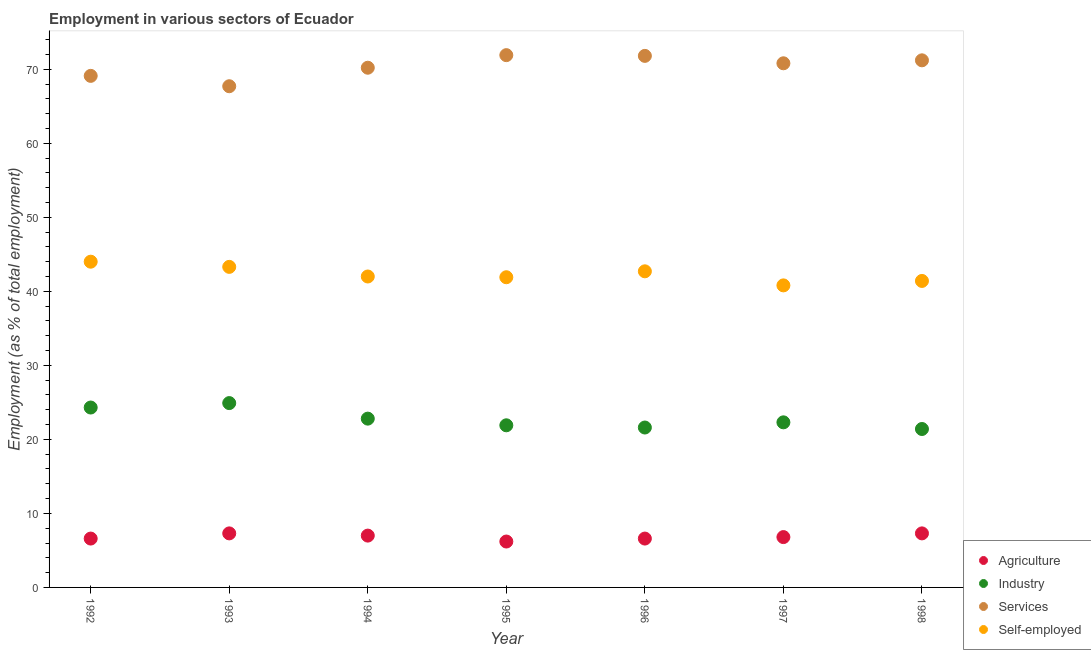Is the number of dotlines equal to the number of legend labels?
Provide a succinct answer. Yes. What is the percentage of workers in industry in 1996?
Provide a short and direct response. 21.6. Across all years, what is the maximum percentage of workers in agriculture?
Offer a terse response. 7.3. Across all years, what is the minimum percentage of workers in industry?
Offer a very short reply. 21.4. What is the total percentage of self employed workers in the graph?
Offer a terse response. 296.1. What is the difference between the percentage of workers in services in 1994 and that in 1998?
Ensure brevity in your answer.  -1. What is the difference between the percentage of workers in industry in 1993 and the percentage of workers in services in 1998?
Your answer should be very brief. -46.3. What is the average percentage of workers in services per year?
Make the answer very short. 70.39. In the year 1994, what is the difference between the percentage of workers in industry and percentage of self employed workers?
Your answer should be very brief. -19.2. In how many years, is the percentage of self employed workers greater than 12 %?
Give a very brief answer. 7. What is the ratio of the percentage of workers in agriculture in 1992 to that in 1994?
Offer a terse response. 0.94. Is the percentage of workers in services in 1994 less than that in 1998?
Offer a very short reply. Yes. What is the difference between the highest and the second highest percentage of self employed workers?
Provide a short and direct response. 0.7. What is the difference between the highest and the lowest percentage of workers in industry?
Keep it short and to the point. 3.5. Is it the case that in every year, the sum of the percentage of workers in agriculture and percentage of workers in industry is greater than the percentage of workers in services?
Keep it short and to the point. No. What is the difference between two consecutive major ticks on the Y-axis?
Provide a succinct answer. 10. Where does the legend appear in the graph?
Provide a succinct answer. Bottom right. What is the title of the graph?
Ensure brevity in your answer.  Employment in various sectors of Ecuador. Does "Management rating" appear as one of the legend labels in the graph?
Keep it short and to the point. No. What is the label or title of the X-axis?
Ensure brevity in your answer.  Year. What is the label or title of the Y-axis?
Provide a short and direct response. Employment (as % of total employment). What is the Employment (as % of total employment) of Agriculture in 1992?
Your response must be concise. 6.6. What is the Employment (as % of total employment) of Industry in 1992?
Make the answer very short. 24.3. What is the Employment (as % of total employment) in Services in 1992?
Provide a succinct answer. 69.1. What is the Employment (as % of total employment) in Agriculture in 1993?
Keep it short and to the point. 7.3. What is the Employment (as % of total employment) of Industry in 1993?
Offer a very short reply. 24.9. What is the Employment (as % of total employment) of Services in 1993?
Ensure brevity in your answer.  67.7. What is the Employment (as % of total employment) of Self-employed in 1993?
Ensure brevity in your answer.  43.3. What is the Employment (as % of total employment) of Industry in 1994?
Provide a succinct answer. 22.8. What is the Employment (as % of total employment) of Services in 1994?
Ensure brevity in your answer.  70.2. What is the Employment (as % of total employment) in Self-employed in 1994?
Your answer should be very brief. 42. What is the Employment (as % of total employment) of Agriculture in 1995?
Give a very brief answer. 6.2. What is the Employment (as % of total employment) of Industry in 1995?
Your answer should be compact. 21.9. What is the Employment (as % of total employment) in Services in 1995?
Your answer should be compact. 71.9. What is the Employment (as % of total employment) in Self-employed in 1995?
Provide a short and direct response. 41.9. What is the Employment (as % of total employment) of Agriculture in 1996?
Your answer should be compact. 6.6. What is the Employment (as % of total employment) in Industry in 1996?
Your answer should be very brief. 21.6. What is the Employment (as % of total employment) in Services in 1996?
Give a very brief answer. 71.8. What is the Employment (as % of total employment) in Self-employed in 1996?
Your response must be concise. 42.7. What is the Employment (as % of total employment) of Agriculture in 1997?
Your response must be concise. 6.8. What is the Employment (as % of total employment) of Industry in 1997?
Ensure brevity in your answer.  22.3. What is the Employment (as % of total employment) of Services in 1997?
Your answer should be very brief. 70.8. What is the Employment (as % of total employment) in Self-employed in 1997?
Offer a very short reply. 40.8. What is the Employment (as % of total employment) of Agriculture in 1998?
Keep it short and to the point. 7.3. What is the Employment (as % of total employment) of Industry in 1998?
Your response must be concise. 21.4. What is the Employment (as % of total employment) of Services in 1998?
Your answer should be compact. 71.2. What is the Employment (as % of total employment) in Self-employed in 1998?
Make the answer very short. 41.4. Across all years, what is the maximum Employment (as % of total employment) of Agriculture?
Your answer should be compact. 7.3. Across all years, what is the maximum Employment (as % of total employment) of Industry?
Make the answer very short. 24.9. Across all years, what is the maximum Employment (as % of total employment) in Services?
Make the answer very short. 71.9. Across all years, what is the minimum Employment (as % of total employment) of Agriculture?
Give a very brief answer. 6.2. Across all years, what is the minimum Employment (as % of total employment) of Industry?
Make the answer very short. 21.4. Across all years, what is the minimum Employment (as % of total employment) in Services?
Your answer should be very brief. 67.7. Across all years, what is the minimum Employment (as % of total employment) in Self-employed?
Offer a very short reply. 40.8. What is the total Employment (as % of total employment) in Agriculture in the graph?
Keep it short and to the point. 47.8. What is the total Employment (as % of total employment) in Industry in the graph?
Keep it short and to the point. 159.2. What is the total Employment (as % of total employment) of Services in the graph?
Give a very brief answer. 492.7. What is the total Employment (as % of total employment) of Self-employed in the graph?
Your answer should be compact. 296.1. What is the difference between the Employment (as % of total employment) in Agriculture in 1992 and that in 1993?
Give a very brief answer. -0.7. What is the difference between the Employment (as % of total employment) of Self-employed in 1992 and that in 1993?
Make the answer very short. 0.7. What is the difference between the Employment (as % of total employment) in Agriculture in 1992 and that in 1994?
Give a very brief answer. -0.4. What is the difference between the Employment (as % of total employment) of Industry in 1992 and that in 1994?
Keep it short and to the point. 1.5. What is the difference between the Employment (as % of total employment) in Services in 1992 and that in 1994?
Your answer should be very brief. -1.1. What is the difference between the Employment (as % of total employment) of Self-employed in 1992 and that in 1994?
Offer a very short reply. 2. What is the difference between the Employment (as % of total employment) of Industry in 1992 and that in 1995?
Your answer should be compact. 2.4. What is the difference between the Employment (as % of total employment) in Self-employed in 1992 and that in 1995?
Offer a very short reply. 2.1. What is the difference between the Employment (as % of total employment) in Industry in 1992 and that in 1996?
Give a very brief answer. 2.7. What is the difference between the Employment (as % of total employment) of Services in 1992 and that in 1997?
Offer a terse response. -1.7. What is the difference between the Employment (as % of total employment) of Agriculture in 1992 and that in 1998?
Make the answer very short. -0.7. What is the difference between the Employment (as % of total employment) of Services in 1992 and that in 1998?
Ensure brevity in your answer.  -2.1. What is the difference between the Employment (as % of total employment) of Self-employed in 1992 and that in 1998?
Provide a succinct answer. 2.6. What is the difference between the Employment (as % of total employment) in Agriculture in 1993 and that in 1994?
Provide a short and direct response. 0.3. What is the difference between the Employment (as % of total employment) of Industry in 1993 and that in 1994?
Offer a terse response. 2.1. What is the difference between the Employment (as % of total employment) of Agriculture in 1993 and that in 1995?
Keep it short and to the point. 1.1. What is the difference between the Employment (as % of total employment) in Industry in 1993 and that in 1995?
Ensure brevity in your answer.  3. What is the difference between the Employment (as % of total employment) of Self-employed in 1993 and that in 1995?
Offer a terse response. 1.4. What is the difference between the Employment (as % of total employment) in Industry in 1993 and that in 1996?
Your response must be concise. 3.3. What is the difference between the Employment (as % of total employment) of Services in 1993 and that in 1996?
Offer a terse response. -4.1. What is the difference between the Employment (as % of total employment) of Industry in 1993 and that in 1997?
Offer a terse response. 2.6. What is the difference between the Employment (as % of total employment) in Agriculture in 1993 and that in 1998?
Your answer should be compact. 0. What is the difference between the Employment (as % of total employment) in Industry in 1993 and that in 1998?
Make the answer very short. 3.5. What is the difference between the Employment (as % of total employment) in Services in 1993 and that in 1998?
Your answer should be very brief. -3.5. What is the difference between the Employment (as % of total employment) in Self-employed in 1993 and that in 1998?
Your answer should be compact. 1.9. What is the difference between the Employment (as % of total employment) of Industry in 1994 and that in 1995?
Your response must be concise. 0.9. What is the difference between the Employment (as % of total employment) in Self-employed in 1994 and that in 1995?
Make the answer very short. 0.1. What is the difference between the Employment (as % of total employment) in Industry in 1994 and that in 1996?
Ensure brevity in your answer.  1.2. What is the difference between the Employment (as % of total employment) of Services in 1994 and that in 1996?
Your answer should be compact. -1.6. What is the difference between the Employment (as % of total employment) in Agriculture in 1994 and that in 1997?
Offer a terse response. 0.2. What is the difference between the Employment (as % of total employment) in Industry in 1994 and that in 1997?
Keep it short and to the point. 0.5. What is the difference between the Employment (as % of total employment) of Services in 1994 and that in 1997?
Give a very brief answer. -0.6. What is the difference between the Employment (as % of total employment) of Self-employed in 1994 and that in 1997?
Give a very brief answer. 1.2. What is the difference between the Employment (as % of total employment) in Self-employed in 1994 and that in 1998?
Provide a succinct answer. 0.6. What is the difference between the Employment (as % of total employment) in Industry in 1995 and that in 1996?
Provide a succinct answer. 0.3. What is the difference between the Employment (as % of total employment) of Industry in 1995 and that in 1997?
Give a very brief answer. -0.4. What is the difference between the Employment (as % of total employment) of Self-employed in 1995 and that in 1997?
Offer a terse response. 1.1. What is the difference between the Employment (as % of total employment) of Self-employed in 1996 and that in 1997?
Ensure brevity in your answer.  1.9. What is the difference between the Employment (as % of total employment) of Agriculture in 1996 and that in 1998?
Your answer should be compact. -0.7. What is the difference between the Employment (as % of total employment) of Self-employed in 1996 and that in 1998?
Your response must be concise. 1.3. What is the difference between the Employment (as % of total employment) in Agriculture in 1992 and the Employment (as % of total employment) in Industry in 1993?
Offer a terse response. -18.3. What is the difference between the Employment (as % of total employment) of Agriculture in 1992 and the Employment (as % of total employment) of Services in 1993?
Your answer should be very brief. -61.1. What is the difference between the Employment (as % of total employment) in Agriculture in 1992 and the Employment (as % of total employment) in Self-employed in 1993?
Make the answer very short. -36.7. What is the difference between the Employment (as % of total employment) in Industry in 1992 and the Employment (as % of total employment) in Services in 1993?
Your answer should be very brief. -43.4. What is the difference between the Employment (as % of total employment) of Services in 1992 and the Employment (as % of total employment) of Self-employed in 1993?
Provide a succinct answer. 25.8. What is the difference between the Employment (as % of total employment) in Agriculture in 1992 and the Employment (as % of total employment) in Industry in 1994?
Your answer should be compact. -16.2. What is the difference between the Employment (as % of total employment) in Agriculture in 1992 and the Employment (as % of total employment) in Services in 1994?
Provide a short and direct response. -63.6. What is the difference between the Employment (as % of total employment) of Agriculture in 1992 and the Employment (as % of total employment) of Self-employed in 1994?
Your response must be concise. -35.4. What is the difference between the Employment (as % of total employment) of Industry in 1992 and the Employment (as % of total employment) of Services in 1994?
Your answer should be compact. -45.9. What is the difference between the Employment (as % of total employment) of Industry in 1992 and the Employment (as % of total employment) of Self-employed in 1994?
Give a very brief answer. -17.7. What is the difference between the Employment (as % of total employment) in Services in 1992 and the Employment (as % of total employment) in Self-employed in 1994?
Ensure brevity in your answer.  27.1. What is the difference between the Employment (as % of total employment) of Agriculture in 1992 and the Employment (as % of total employment) of Industry in 1995?
Offer a very short reply. -15.3. What is the difference between the Employment (as % of total employment) of Agriculture in 1992 and the Employment (as % of total employment) of Services in 1995?
Ensure brevity in your answer.  -65.3. What is the difference between the Employment (as % of total employment) in Agriculture in 1992 and the Employment (as % of total employment) in Self-employed in 1995?
Your answer should be very brief. -35.3. What is the difference between the Employment (as % of total employment) in Industry in 1992 and the Employment (as % of total employment) in Services in 1995?
Your answer should be compact. -47.6. What is the difference between the Employment (as % of total employment) of Industry in 1992 and the Employment (as % of total employment) of Self-employed in 1995?
Your response must be concise. -17.6. What is the difference between the Employment (as % of total employment) in Services in 1992 and the Employment (as % of total employment) in Self-employed in 1995?
Offer a very short reply. 27.2. What is the difference between the Employment (as % of total employment) in Agriculture in 1992 and the Employment (as % of total employment) in Services in 1996?
Offer a very short reply. -65.2. What is the difference between the Employment (as % of total employment) in Agriculture in 1992 and the Employment (as % of total employment) in Self-employed in 1996?
Provide a short and direct response. -36.1. What is the difference between the Employment (as % of total employment) of Industry in 1992 and the Employment (as % of total employment) of Services in 1996?
Your response must be concise. -47.5. What is the difference between the Employment (as % of total employment) of Industry in 1992 and the Employment (as % of total employment) of Self-employed in 1996?
Make the answer very short. -18.4. What is the difference between the Employment (as % of total employment) in Services in 1992 and the Employment (as % of total employment) in Self-employed in 1996?
Your answer should be very brief. 26.4. What is the difference between the Employment (as % of total employment) in Agriculture in 1992 and the Employment (as % of total employment) in Industry in 1997?
Make the answer very short. -15.7. What is the difference between the Employment (as % of total employment) in Agriculture in 1992 and the Employment (as % of total employment) in Services in 1997?
Keep it short and to the point. -64.2. What is the difference between the Employment (as % of total employment) of Agriculture in 1992 and the Employment (as % of total employment) of Self-employed in 1997?
Give a very brief answer. -34.2. What is the difference between the Employment (as % of total employment) of Industry in 1992 and the Employment (as % of total employment) of Services in 1997?
Your answer should be compact. -46.5. What is the difference between the Employment (as % of total employment) of Industry in 1992 and the Employment (as % of total employment) of Self-employed in 1997?
Offer a very short reply. -16.5. What is the difference between the Employment (as % of total employment) in Services in 1992 and the Employment (as % of total employment) in Self-employed in 1997?
Provide a succinct answer. 28.3. What is the difference between the Employment (as % of total employment) in Agriculture in 1992 and the Employment (as % of total employment) in Industry in 1998?
Offer a terse response. -14.8. What is the difference between the Employment (as % of total employment) of Agriculture in 1992 and the Employment (as % of total employment) of Services in 1998?
Your answer should be very brief. -64.6. What is the difference between the Employment (as % of total employment) of Agriculture in 1992 and the Employment (as % of total employment) of Self-employed in 1998?
Your answer should be very brief. -34.8. What is the difference between the Employment (as % of total employment) in Industry in 1992 and the Employment (as % of total employment) in Services in 1998?
Keep it short and to the point. -46.9. What is the difference between the Employment (as % of total employment) in Industry in 1992 and the Employment (as % of total employment) in Self-employed in 1998?
Make the answer very short. -17.1. What is the difference between the Employment (as % of total employment) of Services in 1992 and the Employment (as % of total employment) of Self-employed in 1998?
Keep it short and to the point. 27.7. What is the difference between the Employment (as % of total employment) of Agriculture in 1993 and the Employment (as % of total employment) of Industry in 1994?
Give a very brief answer. -15.5. What is the difference between the Employment (as % of total employment) of Agriculture in 1993 and the Employment (as % of total employment) of Services in 1994?
Offer a very short reply. -62.9. What is the difference between the Employment (as % of total employment) of Agriculture in 1993 and the Employment (as % of total employment) of Self-employed in 1994?
Offer a very short reply. -34.7. What is the difference between the Employment (as % of total employment) of Industry in 1993 and the Employment (as % of total employment) of Services in 1994?
Offer a terse response. -45.3. What is the difference between the Employment (as % of total employment) of Industry in 1993 and the Employment (as % of total employment) of Self-employed in 1994?
Give a very brief answer. -17.1. What is the difference between the Employment (as % of total employment) in Services in 1993 and the Employment (as % of total employment) in Self-employed in 1994?
Your answer should be very brief. 25.7. What is the difference between the Employment (as % of total employment) of Agriculture in 1993 and the Employment (as % of total employment) of Industry in 1995?
Offer a very short reply. -14.6. What is the difference between the Employment (as % of total employment) in Agriculture in 1993 and the Employment (as % of total employment) in Services in 1995?
Offer a terse response. -64.6. What is the difference between the Employment (as % of total employment) of Agriculture in 1993 and the Employment (as % of total employment) of Self-employed in 1995?
Offer a terse response. -34.6. What is the difference between the Employment (as % of total employment) of Industry in 1993 and the Employment (as % of total employment) of Services in 1995?
Your response must be concise. -47. What is the difference between the Employment (as % of total employment) of Industry in 1993 and the Employment (as % of total employment) of Self-employed in 1995?
Your answer should be very brief. -17. What is the difference between the Employment (as % of total employment) of Services in 1993 and the Employment (as % of total employment) of Self-employed in 1995?
Your answer should be compact. 25.8. What is the difference between the Employment (as % of total employment) of Agriculture in 1993 and the Employment (as % of total employment) of Industry in 1996?
Ensure brevity in your answer.  -14.3. What is the difference between the Employment (as % of total employment) of Agriculture in 1993 and the Employment (as % of total employment) of Services in 1996?
Give a very brief answer. -64.5. What is the difference between the Employment (as % of total employment) in Agriculture in 1993 and the Employment (as % of total employment) in Self-employed in 1996?
Provide a succinct answer. -35.4. What is the difference between the Employment (as % of total employment) in Industry in 1993 and the Employment (as % of total employment) in Services in 1996?
Offer a terse response. -46.9. What is the difference between the Employment (as % of total employment) in Industry in 1993 and the Employment (as % of total employment) in Self-employed in 1996?
Give a very brief answer. -17.8. What is the difference between the Employment (as % of total employment) of Services in 1993 and the Employment (as % of total employment) of Self-employed in 1996?
Ensure brevity in your answer.  25. What is the difference between the Employment (as % of total employment) of Agriculture in 1993 and the Employment (as % of total employment) of Industry in 1997?
Keep it short and to the point. -15. What is the difference between the Employment (as % of total employment) of Agriculture in 1993 and the Employment (as % of total employment) of Services in 1997?
Provide a short and direct response. -63.5. What is the difference between the Employment (as % of total employment) in Agriculture in 1993 and the Employment (as % of total employment) in Self-employed in 1997?
Make the answer very short. -33.5. What is the difference between the Employment (as % of total employment) in Industry in 1993 and the Employment (as % of total employment) in Services in 1997?
Keep it short and to the point. -45.9. What is the difference between the Employment (as % of total employment) of Industry in 1993 and the Employment (as % of total employment) of Self-employed in 1997?
Provide a succinct answer. -15.9. What is the difference between the Employment (as % of total employment) of Services in 1993 and the Employment (as % of total employment) of Self-employed in 1997?
Make the answer very short. 26.9. What is the difference between the Employment (as % of total employment) in Agriculture in 1993 and the Employment (as % of total employment) in Industry in 1998?
Ensure brevity in your answer.  -14.1. What is the difference between the Employment (as % of total employment) in Agriculture in 1993 and the Employment (as % of total employment) in Services in 1998?
Ensure brevity in your answer.  -63.9. What is the difference between the Employment (as % of total employment) of Agriculture in 1993 and the Employment (as % of total employment) of Self-employed in 1998?
Your answer should be compact. -34.1. What is the difference between the Employment (as % of total employment) of Industry in 1993 and the Employment (as % of total employment) of Services in 1998?
Make the answer very short. -46.3. What is the difference between the Employment (as % of total employment) of Industry in 1993 and the Employment (as % of total employment) of Self-employed in 1998?
Offer a very short reply. -16.5. What is the difference between the Employment (as % of total employment) of Services in 1993 and the Employment (as % of total employment) of Self-employed in 1998?
Give a very brief answer. 26.3. What is the difference between the Employment (as % of total employment) in Agriculture in 1994 and the Employment (as % of total employment) in Industry in 1995?
Provide a short and direct response. -14.9. What is the difference between the Employment (as % of total employment) in Agriculture in 1994 and the Employment (as % of total employment) in Services in 1995?
Keep it short and to the point. -64.9. What is the difference between the Employment (as % of total employment) of Agriculture in 1994 and the Employment (as % of total employment) of Self-employed in 1995?
Your answer should be compact. -34.9. What is the difference between the Employment (as % of total employment) of Industry in 1994 and the Employment (as % of total employment) of Services in 1995?
Provide a succinct answer. -49.1. What is the difference between the Employment (as % of total employment) of Industry in 1994 and the Employment (as % of total employment) of Self-employed in 1995?
Offer a very short reply. -19.1. What is the difference between the Employment (as % of total employment) in Services in 1994 and the Employment (as % of total employment) in Self-employed in 1995?
Ensure brevity in your answer.  28.3. What is the difference between the Employment (as % of total employment) in Agriculture in 1994 and the Employment (as % of total employment) in Industry in 1996?
Your answer should be compact. -14.6. What is the difference between the Employment (as % of total employment) in Agriculture in 1994 and the Employment (as % of total employment) in Services in 1996?
Your answer should be very brief. -64.8. What is the difference between the Employment (as % of total employment) in Agriculture in 1994 and the Employment (as % of total employment) in Self-employed in 1996?
Provide a short and direct response. -35.7. What is the difference between the Employment (as % of total employment) in Industry in 1994 and the Employment (as % of total employment) in Services in 1996?
Offer a very short reply. -49. What is the difference between the Employment (as % of total employment) in Industry in 1994 and the Employment (as % of total employment) in Self-employed in 1996?
Provide a succinct answer. -19.9. What is the difference between the Employment (as % of total employment) in Services in 1994 and the Employment (as % of total employment) in Self-employed in 1996?
Ensure brevity in your answer.  27.5. What is the difference between the Employment (as % of total employment) of Agriculture in 1994 and the Employment (as % of total employment) of Industry in 1997?
Give a very brief answer. -15.3. What is the difference between the Employment (as % of total employment) of Agriculture in 1994 and the Employment (as % of total employment) of Services in 1997?
Offer a very short reply. -63.8. What is the difference between the Employment (as % of total employment) in Agriculture in 1994 and the Employment (as % of total employment) in Self-employed in 1997?
Make the answer very short. -33.8. What is the difference between the Employment (as % of total employment) of Industry in 1994 and the Employment (as % of total employment) of Services in 1997?
Ensure brevity in your answer.  -48. What is the difference between the Employment (as % of total employment) of Services in 1994 and the Employment (as % of total employment) of Self-employed in 1997?
Offer a very short reply. 29.4. What is the difference between the Employment (as % of total employment) in Agriculture in 1994 and the Employment (as % of total employment) in Industry in 1998?
Keep it short and to the point. -14.4. What is the difference between the Employment (as % of total employment) of Agriculture in 1994 and the Employment (as % of total employment) of Services in 1998?
Offer a terse response. -64.2. What is the difference between the Employment (as % of total employment) in Agriculture in 1994 and the Employment (as % of total employment) in Self-employed in 1998?
Your answer should be compact. -34.4. What is the difference between the Employment (as % of total employment) of Industry in 1994 and the Employment (as % of total employment) of Services in 1998?
Keep it short and to the point. -48.4. What is the difference between the Employment (as % of total employment) in Industry in 1994 and the Employment (as % of total employment) in Self-employed in 1998?
Provide a succinct answer. -18.6. What is the difference between the Employment (as % of total employment) of Services in 1994 and the Employment (as % of total employment) of Self-employed in 1998?
Provide a succinct answer. 28.8. What is the difference between the Employment (as % of total employment) in Agriculture in 1995 and the Employment (as % of total employment) in Industry in 1996?
Offer a very short reply. -15.4. What is the difference between the Employment (as % of total employment) in Agriculture in 1995 and the Employment (as % of total employment) in Services in 1996?
Provide a short and direct response. -65.6. What is the difference between the Employment (as % of total employment) of Agriculture in 1995 and the Employment (as % of total employment) of Self-employed in 1996?
Your answer should be compact. -36.5. What is the difference between the Employment (as % of total employment) of Industry in 1995 and the Employment (as % of total employment) of Services in 1996?
Provide a short and direct response. -49.9. What is the difference between the Employment (as % of total employment) of Industry in 1995 and the Employment (as % of total employment) of Self-employed in 1996?
Provide a short and direct response. -20.8. What is the difference between the Employment (as % of total employment) of Services in 1995 and the Employment (as % of total employment) of Self-employed in 1996?
Your answer should be compact. 29.2. What is the difference between the Employment (as % of total employment) of Agriculture in 1995 and the Employment (as % of total employment) of Industry in 1997?
Your answer should be very brief. -16.1. What is the difference between the Employment (as % of total employment) of Agriculture in 1995 and the Employment (as % of total employment) of Services in 1997?
Offer a very short reply. -64.6. What is the difference between the Employment (as % of total employment) in Agriculture in 1995 and the Employment (as % of total employment) in Self-employed in 1997?
Give a very brief answer. -34.6. What is the difference between the Employment (as % of total employment) of Industry in 1995 and the Employment (as % of total employment) of Services in 1997?
Ensure brevity in your answer.  -48.9. What is the difference between the Employment (as % of total employment) of Industry in 1995 and the Employment (as % of total employment) of Self-employed in 1997?
Your response must be concise. -18.9. What is the difference between the Employment (as % of total employment) of Services in 1995 and the Employment (as % of total employment) of Self-employed in 1997?
Offer a very short reply. 31.1. What is the difference between the Employment (as % of total employment) of Agriculture in 1995 and the Employment (as % of total employment) of Industry in 1998?
Make the answer very short. -15.2. What is the difference between the Employment (as % of total employment) in Agriculture in 1995 and the Employment (as % of total employment) in Services in 1998?
Provide a succinct answer. -65. What is the difference between the Employment (as % of total employment) of Agriculture in 1995 and the Employment (as % of total employment) of Self-employed in 1998?
Offer a very short reply. -35.2. What is the difference between the Employment (as % of total employment) in Industry in 1995 and the Employment (as % of total employment) in Services in 1998?
Make the answer very short. -49.3. What is the difference between the Employment (as % of total employment) of Industry in 1995 and the Employment (as % of total employment) of Self-employed in 1998?
Provide a succinct answer. -19.5. What is the difference between the Employment (as % of total employment) of Services in 1995 and the Employment (as % of total employment) of Self-employed in 1998?
Give a very brief answer. 30.5. What is the difference between the Employment (as % of total employment) in Agriculture in 1996 and the Employment (as % of total employment) in Industry in 1997?
Your answer should be very brief. -15.7. What is the difference between the Employment (as % of total employment) in Agriculture in 1996 and the Employment (as % of total employment) in Services in 1997?
Offer a very short reply. -64.2. What is the difference between the Employment (as % of total employment) in Agriculture in 1996 and the Employment (as % of total employment) in Self-employed in 1997?
Provide a succinct answer. -34.2. What is the difference between the Employment (as % of total employment) in Industry in 1996 and the Employment (as % of total employment) in Services in 1997?
Make the answer very short. -49.2. What is the difference between the Employment (as % of total employment) of Industry in 1996 and the Employment (as % of total employment) of Self-employed in 1997?
Provide a succinct answer. -19.2. What is the difference between the Employment (as % of total employment) of Services in 1996 and the Employment (as % of total employment) of Self-employed in 1997?
Offer a very short reply. 31. What is the difference between the Employment (as % of total employment) of Agriculture in 1996 and the Employment (as % of total employment) of Industry in 1998?
Your answer should be compact. -14.8. What is the difference between the Employment (as % of total employment) of Agriculture in 1996 and the Employment (as % of total employment) of Services in 1998?
Provide a short and direct response. -64.6. What is the difference between the Employment (as % of total employment) of Agriculture in 1996 and the Employment (as % of total employment) of Self-employed in 1998?
Keep it short and to the point. -34.8. What is the difference between the Employment (as % of total employment) of Industry in 1996 and the Employment (as % of total employment) of Services in 1998?
Provide a short and direct response. -49.6. What is the difference between the Employment (as % of total employment) in Industry in 1996 and the Employment (as % of total employment) in Self-employed in 1998?
Offer a terse response. -19.8. What is the difference between the Employment (as % of total employment) in Services in 1996 and the Employment (as % of total employment) in Self-employed in 1998?
Keep it short and to the point. 30.4. What is the difference between the Employment (as % of total employment) in Agriculture in 1997 and the Employment (as % of total employment) in Industry in 1998?
Offer a very short reply. -14.6. What is the difference between the Employment (as % of total employment) in Agriculture in 1997 and the Employment (as % of total employment) in Services in 1998?
Keep it short and to the point. -64.4. What is the difference between the Employment (as % of total employment) in Agriculture in 1997 and the Employment (as % of total employment) in Self-employed in 1998?
Your answer should be very brief. -34.6. What is the difference between the Employment (as % of total employment) in Industry in 1997 and the Employment (as % of total employment) in Services in 1998?
Provide a succinct answer. -48.9. What is the difference between the Employment (as % of total employment) in Industry in 1997 and the Employment (as % of total employment) in Self-employed in 1998?
Give a very brief answer. -19.1. What is the difference between the Employment (as % of total employment) in Services in 1997 and the Employment (as % of total employment) in Self-employed in 1998?
Ensure brevity in your answer.  29.4. What is the average Employment (as % of total employment) in Agriculture per year?
Keep it short and to the point. 6.83. What is the average Employment (as % of total employment) of Industry per year?
Your response must be concise. 22.74. What is the average Employment (as % of total employment) in Services per year?
Offer a very short reply. 70.39. What is the average Employment (as % of total employment) in Self-employed per year?
Offer a terse response. 42.3. In the year 1992, what is the difference between the Employment (as % of total employment) in Agriculture and Employment (as % of total employment) in Industry?
Give a very brief answer. -17.7. In the year 1992, what is the difference between the Employment (as % of total employment) of Agriculture and Employment (as % of total employment) of Services?
Ensure brevity in your answer.  -62.5. In the year 1992, what is the difference between the Employment (as % of total employment) in Agriculture and Employment (as % of total employment) in Self-employed?
Your response must be concise. -37.4. In the year 1992, what is the difference between the Employment (as % of total employment) of Industry and Employment (as % of total employment) of Services?
Provide a short and direct response. -44.8. In the year 1992, what is the difference between the Employment (as % of total employment) in Industry and Employment (as % of total employment) in Self-employed?
Keep it short and to the point. -19.7. In the year 1992, what is the difference between the Employment (as % of total employment) in Services and Employment (as % of total employment) in Self-employed?
Your response must be concise. 25.1. In the year 1993, what is the difference between the Employment (as % of total employment) of Agriculture and Employment (as % of total employment) of Industry?
Your answer should be very brief. -17.6. In the year 1993, what is the difference between the Employment (as % of total employment) of Agriculture and Employment (as % of total employment) of Services?
Your answer should be compact. -60.4. In the year 1993, what is the difference between the Employment (as % of total employment) in Agriculture and Employment (as % of total employment) in Self-employed?
Your answer should be very brief. -36. In the year 1993, what is the difference between the Employment (as % of total employment) of Industry and Employment (as % of total employment) of Services?
Provide a succinct answer. -42.8. In the year 1993, what is the difference between the Employment (as % of total employment) in Industry and Employment (as % of total employment) in Self-employed?
Offer a very short reply. -18.4. In the year 1993, what is the difference between the Employment (as % of total employment) in Services and Employment (as % of total employment) in Self-employed?
Make the answer very short. 24.4. In the year 1994, what is the difference between the Employment (as % of total employment) of Agriculture and Employment (as % of total employment) of Industry?
Keep it short and to the point. -15.8. In the year 1994, what is the difference between the Employment (as % of total employment) of Agriculture and Employment (as % of total employment) of Services?
Make the answer very short. -63.2. In the year 1994, what is the difference between the Employment (as % of total employment) in Agriculture and Employment (as % of total employment) in Self-employed?
Keep it short and to the point. -35. In the year 1994, what is the difference between the Employment (as % of total employment) of Industry and Employment (as % of total employment) of Services?
Your answer should be very brief. -47.4. In the year 1994, what is the difference between the Employment (as % of total employment) of Industry and Employment (as % of total employment) of Self-employed?
Offer a terse response. -19.2. In the year 1994, what is the difference between the Employment (as % of total employment) of Services and Employment (as % of total employment) of Self-employed?
Your answer should be very brief. 28.2. In the year 1995, what is the difference between the Employment (as % of total employment) in Agriculture and Employment (as % of total employment) in Industry?
Ensure brevity in your answer.  -15.7. In the year 1995, what is the difference between the Employment (as % of total employment) in Agriculture and Employment (as % of total employment) in Services?
Offer a very short reply. -65.7. In the year 1995, what is the difference between the Employment (as % of total employment) in Agriculture and Employment (as % of total employment) in Self-employed?
Provide a short and direct response. -35.7. In the year 1996, what is the difference between the Employment (as % of total employment) in Agriculture and Employment (as % of total employment) in Services?
Give a very brief answer. -65.2. In the year 1996, what is the difference between the Employment (as % of total employment) of Agriculture and Employment (as % of total employment) of Self-employed?
Keep it short and to the point. -36.1. In the year 1996, what is the difference between the Employment (as % of total employment) in Industry and Employment (as % of total employment) in Services?
Your answer should be compact. -50.2. In the year 1996, what is the difference between the Employment (as % of total employment) of Industry and Employment (as % of total employment) of Self-employed?
Provide a succinct answer. -21.1. In the year 1996, what is the difference between the Employment (as % of total employment) in Services and Employment (as % of total employment) in Self-employed?
Give a very brief answer. 29.1. In the year 1997, what is the difference between the Employment (as % of total employment) in Agriculture and Employment (as % of total employment) in Industry?
Your response must be concise. -15.5. In the year 1997, what is the difference between the Employment (as % of total employment) in Agriculture and Employment (as % of total employment) in Services?
Provide a succinct answer. -64. In the year 1997, what is the difference between the Employment (as % of total employment) in Agriculture and Employment (as % of total employment) in Self-employed?
Keep it short and to the point. -34. In the year 1997, what is the difference between the Employment (as % of total employment) of Industry and Employment (as % of total employment) of Services?
Your response must be concise. -48.5. In the year 1997, what is the difference between the Employment (as % of total employment) in Industry and Employment (as % of total employment) in Self-employed?
Give a very brief answer. -18.5. In the year 1997, what is the difference between the Employment (as % of total employment) of Services and Employment (as % of total employment) of Self-employed?
Ensure brevity in your answer.  30. In the year 1998, what is the difference between the Employment (as % of total employment) in Agriculture and Employment (as % of total employment) in Industry?
Provide a short and direct response. -14.1. In the year 1998, what is the difference between the Employment (as % of total employment) in Agriculture and Employment (as % of total employment) in Services?
Provide a succinct answer. -63.9. In the year 1998, what is the difference between the Employment (as % of total employment) of Agriculture and Employment (as % of total employment) of Self-employed?
Your answer should be very brief. -34.1. In the year 1998, what is the difference between the Employment (as % of total employment) of Industry and Employment (as % of total employment) of Services?
Your response must be concise. -49.8. In the year 1998, what is the difference between the Employment (as % of total employment) of Services and Employment (as % of total employment) of Self-employed?
Provide a succinct answer. 29.8. What is the ratio of the Employment (as % of total employment) of Agriculture in 1992 to that in 1993?
Keep it short and to the point. 0.9. What is the ratio of the Employment (as % of total employment) of Industry in 1992 to that in 1993?
Your answer should be compact. 0.98. What is the ratio of the Employment (as % of total employment) in Services in 1992 to that in 1993?
Your answer should be compact. 1.02. What is the ratio of the Employment (as % of total employment) of Self-employed in 1992 to that in 1993?
Ensure brevity in your answer.  1.02. What is the ratio of the Employment (as % of total employment) in Agriculture in 1992 to that in 1994?
Make the answer very short. 0.94. What is the ratio of the Employment (as % of total employment) of Industry in 1992 to that in 1994?
Make the answer very short. 1.07. What is the ratio of the Employment (as % of total employment) of Services in 1992 to that in 1994?
Offer a terse response. 0.98. What is the ratio of the Employment (as % of total employment) in Self-employed in 1992 to that in 1994?
Provide a short and direct response. 1.05. What is the ratio of the Employment (as % of total employment) of Agriculture in 1992 to that in 1995?
Keep it short and to the point. 1.06. What is the ratio of the Employment (as % of total employment) in Industry in 1992 to that in 1995?
Your answer should be very brief. 1.11. What is the ratio of the Employment (as % of total employment) of Services in 1992 to that in 1995?
Give a very brief answer. 0.96. What is the ratio of the Employment (as % of total employment) of Self-employed in 1992 to that in 1995?
Keep it short and to the point. 1.05. What is the ratio of the Employment (as % of total employment) of Services in 1992 to that in 1996?
Provide a succinct answer. 0.96. What is the ratio of the Employment (as % of total employment) in Self-employed in 1992 to that in 1996?
Your answer should be very brief. 1.03. What is the ratio of the Employment (as % of total employment) in Agriculture in 1992 to that in 1997?
Ensure brevity in your answer.  0.97. What is the ratio of the Employment (as % of total employment) of Industry in 1992 to that in 1997?
Give a very brief answer. 1.09. What is the ratio of the Employment (as % of total employment) of Self-employed in 1992 to that in 1997?
Your answer should be compact. 1.08. What is the ratio of the Employment (as % of total employment) in Agriculture in 1992 to that in 1998?
Ensure brevity in your answer.  0.9. What is the ratio of the Employment (as % of total employment) of Industry in 1992 to that in 1998?
Provide a succinct answer. 1.14. What is the ratio of the Employment (as % of total employment) of Services in 1992 to that in 1998?
Provide a short and direct response. 0.97. What is the ratio of the Employment (as % of total employment) of Self-employed in 1992 to that in 1998?
Make the answer very short. 1.06. What is the ratio of the Employment (as % of total employment) of Agriculture in 1993 to that in 1994?
Your answer should be very brief. 1.04. What is the ratio of the Employment (as % of total employment) of Industry in 1993 to that in 1994?
Provide a short and direct response. 1.09. What is the ratio of the Employment (as % of total employment) in Services in 1993 to that in 1994?
Provide a short and direct response. 0.96. What is the ratio of the Employment (as % of total employment) of Self-employed in 1993 to that in 1994?
Offer a terse response. 1.03. What is the ratio of the Employment (as % of total employment) of Agriculture in 1993 to that in 1995?
Offer a very short reply. 1.18. What is the ratio of the Employment (as % of total employment) of Industry in 1993 to that in 1995?
Offer a terse response. 1.14. What is the ratio of the Employment (as % of total employment) of Services in 1993 to that in 1995?
Your answer should be very brief. 0.94. What is the ratio of the Employment (as % of total employment) of Self-employed in 1993 to that in 1995?
Give a very brief answer. 1.03. What is the ratio of the Employment (as % of total employment) in Agriculture in 1993 to that in 1996?
Offer a very short reply. 1.11. What is the ratio of the Employment (as % of total employment) in Industry in 1993 to that in 1996?
Your answer should be very brief. 1.15. What is the ratio of the Employment (as % of total employment) of Services in 1993 to that in 1996?
Ensure brevity in your answer.  0.94. What is the ratio of the Employment (as % of total employment) in Self-employed in 1993 to that in 1996?
Offer a very short reply. 1.01. What is the ratio of the Employment (as % of total employment) of Agriculture in 1993 to that in 1997?
Give a very brief answer. 1.07. What is the ratio of the Employment (as % of total employment) in Industry in 1993 to that in 1997?
Give a very brief answer. 1.12. What is the ratio of the Employment (as % of total employment) in Services in 1993 to that in 1997?
Offer a terse response. 0.96. What is the ratio of the Employment (as % of total employment) of Self-employed in 1993 to that in 1997?
Offer a very short reply. 1.06. What is the ratio of the Employment (as % of total employment) in Agriculture in 1993 to that in 1998?
Your answer should be very brief. 1. What is the ratio of the Employment (as % of total employment) of Industry in 1993 to that in 1998?
Offer a terse response. 1.16. What is the ratio of the Employment (as % of total employment) of Services in 1993 to that in 1998?
Your answer should be compact. 0.95. What is the ratio of the Employment (as % of total employment) in Self-employed in 1993 to that in 1998?
Keep it short and to the point. 1.05. What is the ratio of the Employment (as % of total employment) of Agriculture in 1994 to that in 1995?
Your answer should be compact. 1.13. What is the ratio of the Employment (as % of total employment) of Industry in 1994 to that in 1995?
Your response must be concise. 1.04. What is the ratio of the Employment (as % of total employment) of Services in 1994 to that in 1995?
Make the answer very short. 0.98. What is the ratio of the Employment (as % of total employment) in Agriculture in 1994 to that in 1996?
Ensure brevity in your answer.  1.06. What is the ratio of the Employment (as % of total employment) in Industry in 1994 to that in 1996?
Keep it short and to the point. 1.06. What is the ratio of the Employment (as % of total employment) in Services in 1994 to that in 1996?
Provide a succinct answer. 0.98. What is the ratio of the Employment (as % of total employment) in Self-employed in 1994 to that in 1996?
Offer a very short reply. 0.98. What is the ratio of the Employment (as % of total employment) in Agriculture in 1994 to that in 1997?
Your answer should be compact. 1.03. What is the ratio of the Employment (as % of total employment) of Industry in 1994 to that in 1997?
Provide a short and direct response. 1.02. What is the ratio of the Employment (as % of total employment) in Self-employed in 1994 to that in 1997?
Provide a short and direct response. 1.03. What is the ratio of the Employment (as % of total employment) in Agriculture in 1994 to that in 1998?
Offer a terse response. 0.96. What is the ratio of the Employment (as % of total employment) in Industry in 1994 to that in 1998?
Your answer should be compact. 1.07. What is the ratio of the Employment (as % of total employment) in Self-employed in 1994 to that in 1998?
Your answer should be very brief. 1.01. What is the ratio of the Employment (as % of total employment) in Agriculture in 1995 to that in 1996?
Ensure brevity in your answer.  0.94. What is the ratio of the Employment (as % of total employment) of Industry in 1995 to that in 1996?
Your response must be concise. 1.01. What is the ratio of the Employment (as % of total employment) of Services in 1995 to that in 1996?
Offer a very short reply. 1. What is the ratio of the Employment (as % of total employment) of Self-employed in 1995 to that in 1996?
Your answer should be compact. 0.98. What is the ratio of the Employment (as % of total employment) of Agriculture in 1995 to that in 1997?
Provide a short and direct response. 0.91. What is the ratio of the Employment (as % of total employment) of Industry in 1995 to that in 1997?
Offer a terse response. 0.98. What is the ratio of the Employment (as % of total employment) of Services in 1995 to that in 1997?
Ensure brevity in your answer.  1.02. What is the ratio of the Employment (as % of total employment) of Agriculture in 1995 to that in 1998?
Your answer should be compact. 0.85. What is the ratio of the Employment (as % of total employment) in Industry in 1995 to that in 1998?
Offer a very short reply. 1.02. What is the ratio of the Employment (as % of total employment) of Services in 1995 to that in 1998?
Make the answer very short. 1.01. What is the ratio of the Employment (as % of total employment) in Self-employed in 1995 to that in 1998?
Offer a terse response. 1.01. What is the ratio of the Employment (as % of total employment) in Agriculture in 1996 to that in 1997?
Provide a succinct answer. 0.97. What is the ratio of the Employment (as % of total employment) of Industry in 1996 to that in 1997?
Make the answer very short. 0.97. What is the ratio of the Employment (as % of total employment) in Services in 1996 to that in 1997?
Ensure brevity in your answer.  1.01. What is the ratio of the Employment (as % of total employment) of Self-employed in 1996 to that in 1997?
Offer a very short reply. 1.05. What is the ratio of the Employment (as % of total employment) in Agriculture in 1996 to that in 1998?
Offer a terse response. 0.9. What is the ratio of the Employment (as % of total employment) of Industry in 1996 to that in 1998?
Provide a succinct answer. 1.01. What is the ratio of the Employment (as % of total employment) of Services in 1996 to that in 1998?
Keep it short and to the point. 1.01. What is the ratio of the Employment (as % of total employment) of Self-employed in 1996 to that in 1998?
Keep it short and to the point. 1.03. What is the ratio of the Employment (as % of total employment) of Agriculture in 1997 to that in 1998?
Your answer should be compact. 0.93. What is the ratio of the Employment (as % of total employment) in Industry in 1997 to that in 1998?
Provide a short and direct response. 1.04. What is the ratio of the Employment (as % of total employment) of Self-employed in 1997 to that in 1998?
Offer a very short reply. 0.99. What is the difference between the highest and the second highest Employment (as % of total employment) of Agriculture?
Your answer should be very brief. 0. What is the difference between the highest and the second highest Employment (as % of total employment) of Services?
Make the answer very short. 0.1. What is the difference between the highest and the lowest Employment (as % of total employment) in Industry?
Your response must be concise. 3.5. 